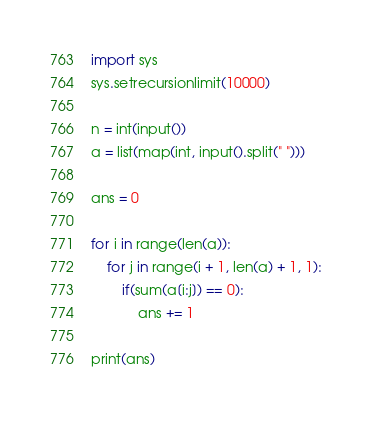<code> <loc_0><loc_0><loc_500><loc_500><_Python_>import sys
sys.setrecursionlimit(10000)

n = int(input())
a = list(map(int, input().split(" ")))

ans = 0

for i in range(len(a)):
    for j in range(i + 1, len(a) + 1, 1):
        if(sum(a[i:j]) == 0):
            ans += 1 

print(ans)</code> 